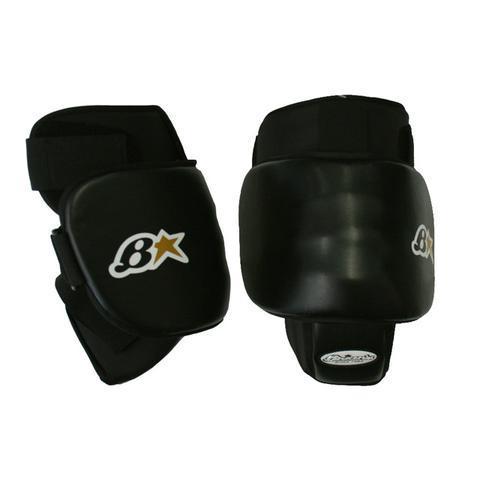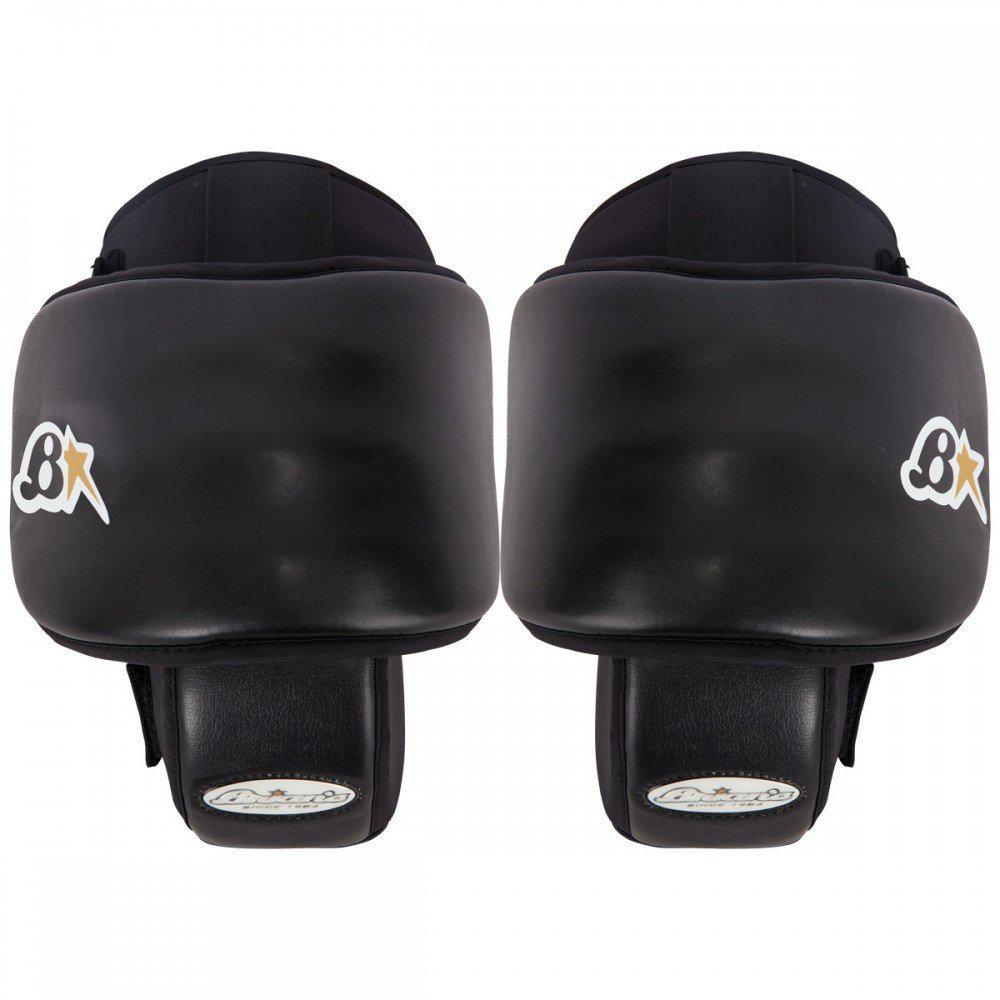The first image is the image on the left, the second image is the image on the right. For the images shown, is this caption "The two black knee pads face opposite directions." true? Answer yes or no. No. 